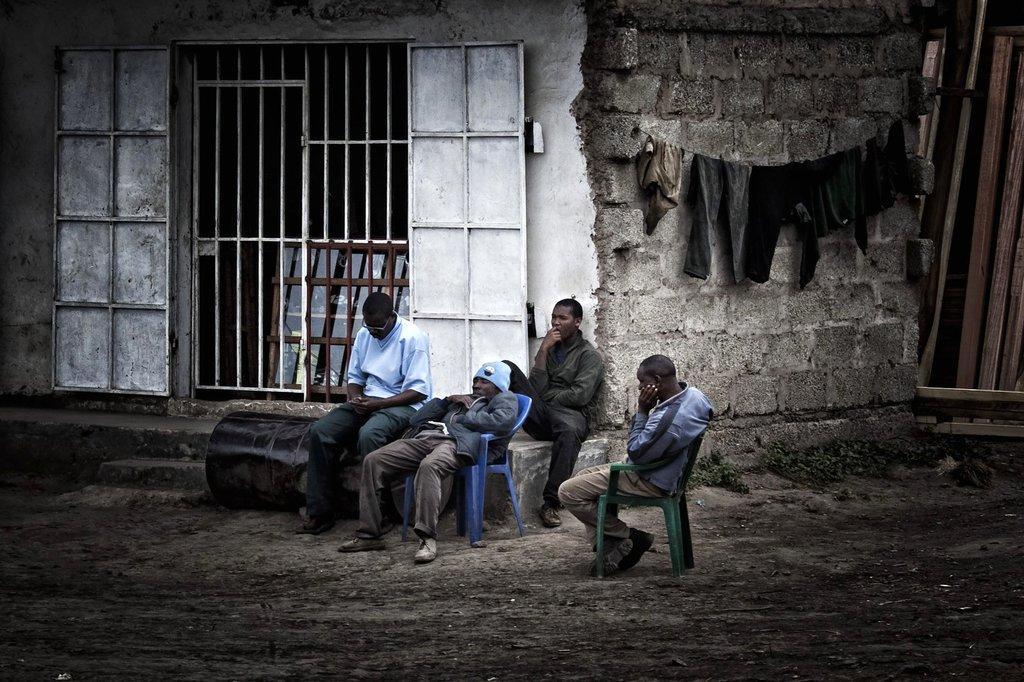How would you summarize this image in a sentence or two? In this image I can see the ground, few chairs and few persons sitting. I can see a black colored barrel and a person sitting on it. I can see a house, a metal gate and few clothes hanged to the rope. 